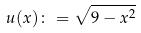Convert formula to latex. <formula><loc_0><loc_0><loc_500><loc_500>u ( x ) \colon = \sqrt { 9 - x ^ { 2 } }</formula> 